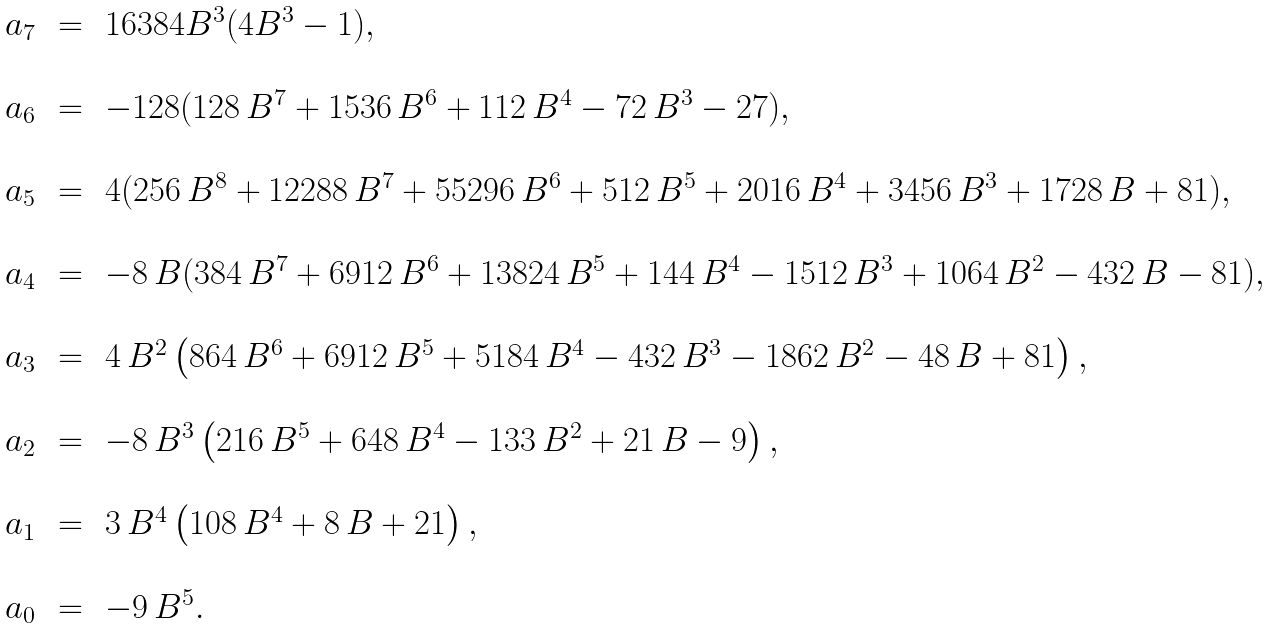Convert formula to latex. <formula><loc_0><loc_0><loc_500><loc_500>\begin{array} { r c l } a _ { 7 } \, & = \, & 1 6 3 8 4 B ^ { 3 } ( 4 B ^ { 3 } - 1 ) , \\ \\ a _ { 6 } \, & = \, & - 1 2 8 ( 1 2 8 \, B ^ { 7 } + 1 5 3 6 \, B ^ { 6 } + 1 1 2 \, B ^ { 4 } - 7 2 \, B ^ { 3 } - 2 7 ) , \\ \\ a _ { 5 } \, & = \, & 4 ( 2 5 6 \, { B } ^ { 8 } + 1 2 2 8 8 \, { B } ^ { 7 } + 5 5 2 9 6 \, { B } ^ { 6 } + 5 1 2 \, { B } ^ { 5 } + 2 0 1 6 \, { B } ^ { 4 } + 3 4 5 6 \, { B } ^ { 3 } + 1 7 2 8 \, B + 8 1 ) , \\ \\ a _ { 4 } \, & = \, & - 8 \, B ( 3 8 4 \, { B } ^ { 7 } + 6 9 1 2 \, { B } ^ { 6 } + 1 3 8 2 4 \, { B } ^ { 5 } + 1 4 4 \, { B } ^ { 4 } - 1 5 1 2 \, { B } ^ { 3 } + 1 0 6 4 \, { B } ^ { 2 } - 4 3 2 \, B - 8 1 ) , \\ \\ a _ { 3 } \, & = \, & 4 \, B ^ { 2 } \left ( 8 6 4 \, { B } ^ { 6 } + 6 9 1 2 \, { B } ^ { 5 } + 5 1 8 4 \, { B } ^ { 4 } - 4 3 2 \, { B } ^ { 3 } - 1 8 6 2 \, { B } ^ { 2 } - 4 8 \, { B } + 8 1 \right ) , \\ \\ a _ { 2 } \, & = \, & - 8 \, { B } ^ { 3 } \left ( 2 1 6 \, { B } ^ { 5 } + 6 4 8 \, { B } ^ { 4 } - 1 3 3 \, { B } ^ { 2 } + 2 1 \, { B } - 9 \right ) , \\ \\ a _ { 1 } \, & = \, & 3 \, { B } ^ { 4 } \left ( 1 0 8 \, { B } ^ { 4 } + 8 \, { B } + 2 1 \right ) , \\ \\ a _ { 0 } \, & = \, & - 9 \, B ^ { 5 } . \\ \end{array}</formula> 